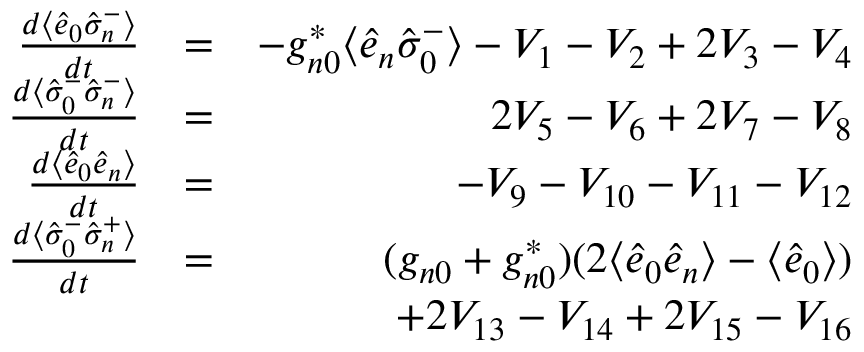Convert formula to latex. <formula><loc_0><loc_0><loc_500><loc_500>\begin{array} { r l r } { \frac { d \langle \hat { e } _ { 0 } \hat { \sigma } _ { n } ^ { - } \rangle } { d t } } & { = } & { - g _ { n 0 } ^ { * } \langle \hat { e } _ { n } \hat { \sigma } _ { 0 } ^ { - } \rangle - V _ { 1 } - V _ { 2 } + 2 V _ { 3 } - V _ { 4 } } \\ { \frac { d \langle \hat { \sigma } _ { 0 } ^ { - } \hat { \sigma } _ { n } ^ { - } \rangle } { d t } } & { = } & { 2 V _ { 5 } - V _ { 6 } + 2 V _ { 7 } - V _ { 8 } } \\ { \frac { d \langle \hat { e } _ { 0 } \hat { e } _ { n } \rangle } { d t } } & { = } & { - V _ { 9 } - V _ { 1 0 } - V _ { 1 1 } - V _ { 1 2 } } \\ { \frac { d \langle \hat { \sigma } _ { 0 } ^ { - } \hat { \sigma } _ { n } ^ { + } \rangle } { d t } } & { = } & { ( g _ { n 0 } + g _ { n 0 } ^ { * } ) ( 2 \langle \hat { e } _ { 0 } \hat { e } _ { n } \rangle - \langle \hat { e } _ { 0 } \rangle ) } \\ & { \null } & { + 2 V _ { 1 3 } - V _ { 1 4 } + 2 V _ { 1 5 } - V _ { 1 6 } } \end{array}</formula> 